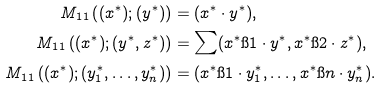Convert formula to latex. <formula><loc_0><loc_0><loc_500><loc_500>M _ { 1 1 } \left ( ( x ^ { * } ) ; ( y ^ { * } ) \right ) & = ( x ^ { * } \cdot y ^ { * } ) , \\ M _ { 1 1 } \left ( ( x ^ { * } ) ; ( y ^ { * } , z ^ { * } ) \right ) & = \sum ( x ^ { * } \i 1 \cdot y ^ { * } , x ^ { * } \i 2 \cdot z ^ { * } ) , \\ M _ { 1 1 } \left ( ( x ^ { * } ) ; ( y ^ { * } _ { 1 } , \dots , y ^ { * } _ { n } ) \right ) & = ( x ^ { * } \i 1 \cdot y ^ { * } _ { 1 } , \dots , x ^ { * } \i { n } \cdot y ^ { * } _ { n } ) .</formula> 